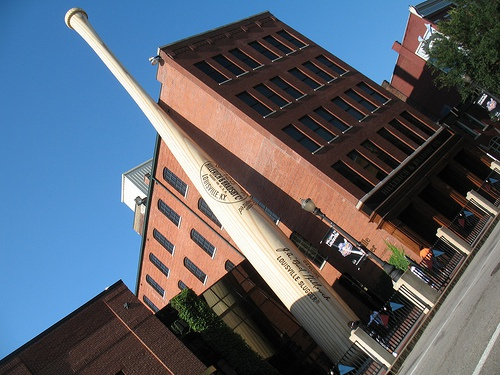Describe the objects in this image and their specific colors. I can see baseball bat in blue, ivory, gray, and tan tones, people in blue, black, gray, darkgray, and lightgray tones, people in blue, black, orange, maroon, and brown tones, people in blue, black, white, gray, and darkgray tones, and people in blue, black, navy, and maroon tones in this image. 